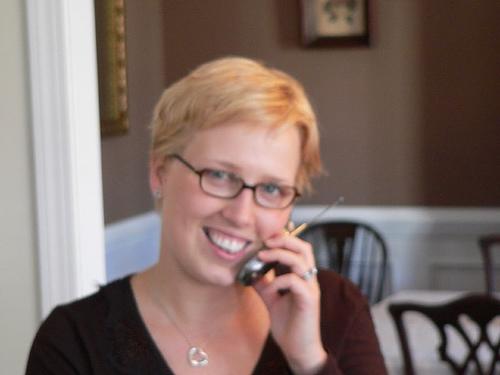Is she on the phone?
Quick response, please. Yes. What gage is this woman's earring?
Write a very short answer. 10. What room in the house is behind the woman?
Write a very short answer. Dining room. How many rings does she have on?
Give a very brief answer. 1. IS she smiling?
Concise answer only. Yes. Is the woman listening, or speaking?
Keep it brief. Listening. Is this woman on the cell phone wearing glasses?
Keep it brief. Yes. What does she have her hand on?
Write a very short answer. Phone. 